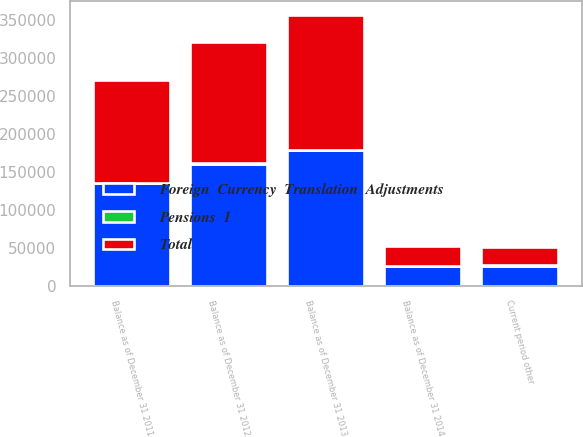Convert chart. <chart><loc_0><loc_0><loc_500><loc_500><stacked_bar_chart><ecel><fcel>Balance as of December 31 2011<fcel>Current period other<fcel>Balance as of December 31 2012<fcel>Balance as of December 31 2013<fcel>Balance as of December 31 2014<nl><fcel>Foreign  Currency  Translation  Adjustments<fcel>134976<fcel>25685<fcel>160661<fcel>178846<fcel>25685<nl><fcel>Pensions  1<fcel>663<fcel>1591<fcel>928<fcel>157<fcel>816<nl><fcel>Total<fcel>135639<fcel>24094<fcel>159733<fcel>178689<fcel>25685<nl></chart> 